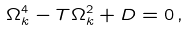<formula> <loc_0><loc_0><loc_500><loc_500>\Omega _ { k } ^ { 4 } - T \Omega _ { k } ^ { 2 } + D = 0 \, ,</formula> 